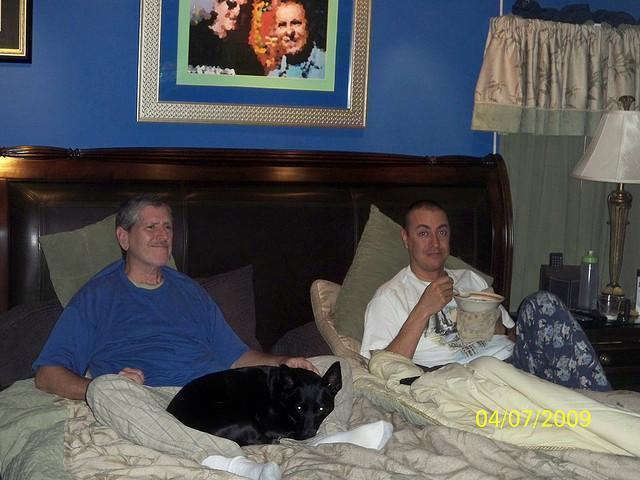How are these men related?
Indicate the correct choice and explain in the format: 'Answer: answer
Rationale: rationale.'
Options: Lovers, arch villians, siblings, enemies. Answer: lovers.
Rationale: Two men are comfortable in bed watching television and laying with a dog. 